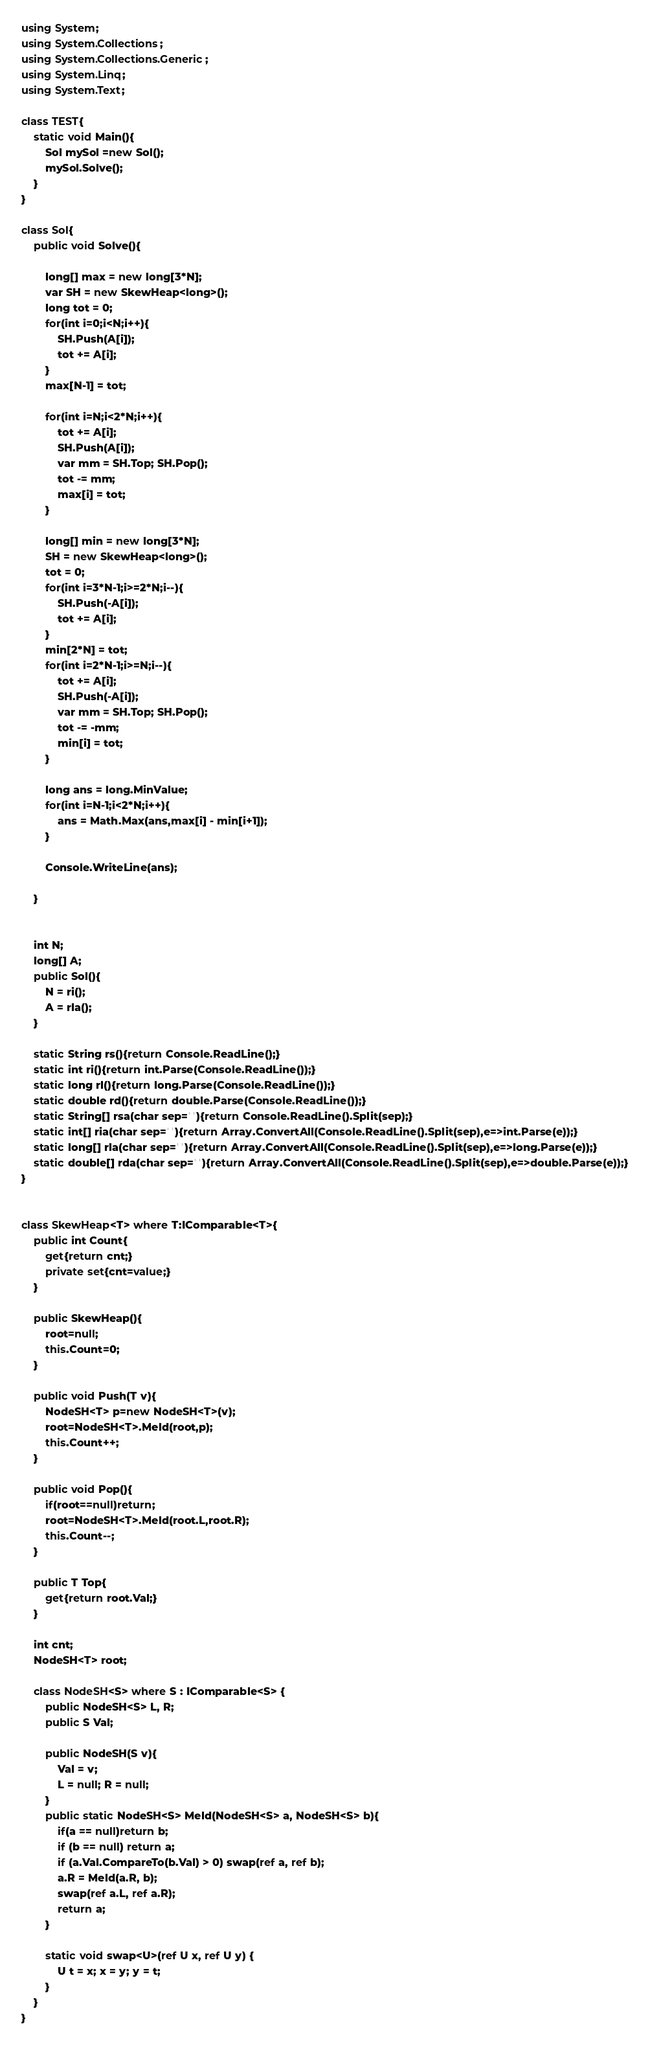<code> <loc_0><loc_0><loc_500><loc_500><_C#_>using System;
using System.Collections;
using System.Collections.Generic;
using System.Linq;
using System.Text;

class TEST{
	static void Main(){
		Sol mySol =new Sol();
		mySol.Solve();
	}
}

class Sol{
	public void Solve(){
		
		long[] max = new long[3*N];
		var SH = new SkewHeap<long>();
		long tot = 0;
		for(int i=0;i<N;i++){
			SH.Push(A[i]);
			tot += A[i];
		}
		max[N-1] = tot;
		
		for(int i=N;i<2*N;i++){
			tot += A[i];
			SH.Push(A[i]);
			var mm = SH.Top; SH.Pop();
			tot -= mm;
			max[i] = tot;
		}
		
		long[] min = new long[3*N];
		SH = new SkewHeap<long>();
		tot = 0;
		for(int i=3*N-1;i>=2*N;i--){
			SH.Push(-A[i]);
			tot += A[i];
		}
		min[2*N] = tot;
		for(int i=2*N-1;i>=N;i--){
			tot += A[i];
			SH.Push(-A[i]);
			var mm = SH.Top; SH.Pop();
			tot -= -mm;
			min[i] = tot;
		}
		
		long ans = long.MinValue;
		for(int i=N-1;i<2*N;i++){
			ans = Math.Max(ans,max[i] - min[i+1]);
		}
		
		Console.WriteLine(ans);
		
	}
	
	
	int N;
	long[] A;
	public Sol(){
		N = ri();
		A = rla();
	}

	static String rs(){return Console.ReadLine();}
	static int ri(){return int.Parse(Console.ReadLine());}
	static long rl(){return long.Parse(Console.ReadLine());}
	static double rd(){return double.Parse(Console.ReadLine());}
	static String[] rsa(char sep=' '){return Console.ReadLine().Split(sep);}
	static int[] ria(char sep=' '){return Array.ConvertAll(Console.ReadLine().Split(sep),e=>int.Parse(e));}
	static long[] rla(char sep=' '){return Array.ConvertAll(Console.ReadLine().Split(sep),e=>long.Parse(e));}
	static double[] rda(char sep=' '){return Array.ConvertAll(Console.ReadLine().Split(sep),e=>double.Parse(e));}
}


class SkewHeap<T> where T:IComparable<T>{
	public int Count{
		get{return cnt;}
		private set{cnt=value;}
	}
	
	public SkewHeap(){
		root=null;
		this.Count=0;
	}
	
	public void Push(T v){
		NodeSH<T> p=new NodeSH<T>(v);
		root=NodeSH<T>.Meld(root,p);
		this.Count++;
	}
	
	public void Pop(){
		if(root==null)return;
		root=NodeSH<T>.Meld(root.L,root.R);
		this.Count--;
	}
	
	public T Top{
		get{return root.Val;}
	}
	
	int cnt;
	NodeSH<T> root;
	
	class NodeSH<S> where S : IComparable<S> {
		public NodeSH<S> L, R;
		public S Val;

		public NodeSH(S v){
			Val = v;
			L = null; R = null;
		}
		public static NodeSH<S> Meld(NodeSH<S> a, NodeSH<S> b){
			if(a == null)return b;
			if (b == null) return a;
			if (a.Val.CompareTo(b.Val) > 0) swap(ref a, ref b);
			a.R = Meld(a.R, b);
			swap(ref a.L, ref a.R);
			return a;
		}

		static void swap<U>(ref U x, ref U y) {
			U t = x; x = y; y = t;
		}
	}
}

</code> 